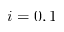Convert formula to latex. <formula><loc_0><loc_0><loc_500><loc_500>i = 0 , 1</formula> 